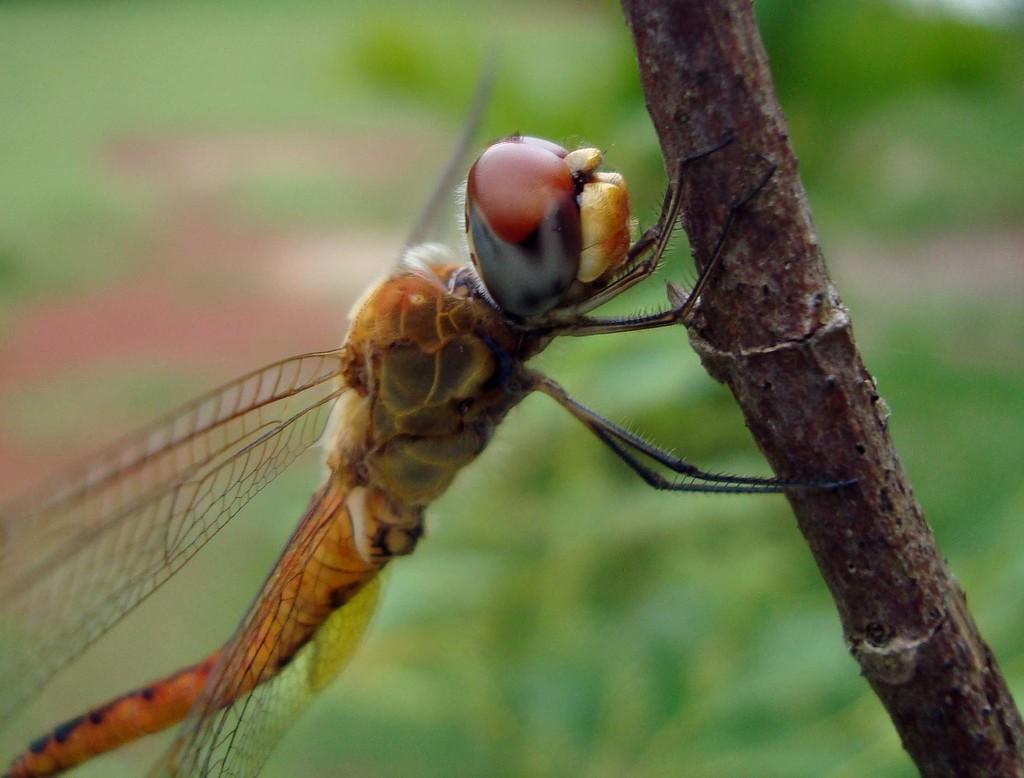In one or two sentences, can you explain what this image depicts? In this image we can see a house fly on the branch of a tree. 